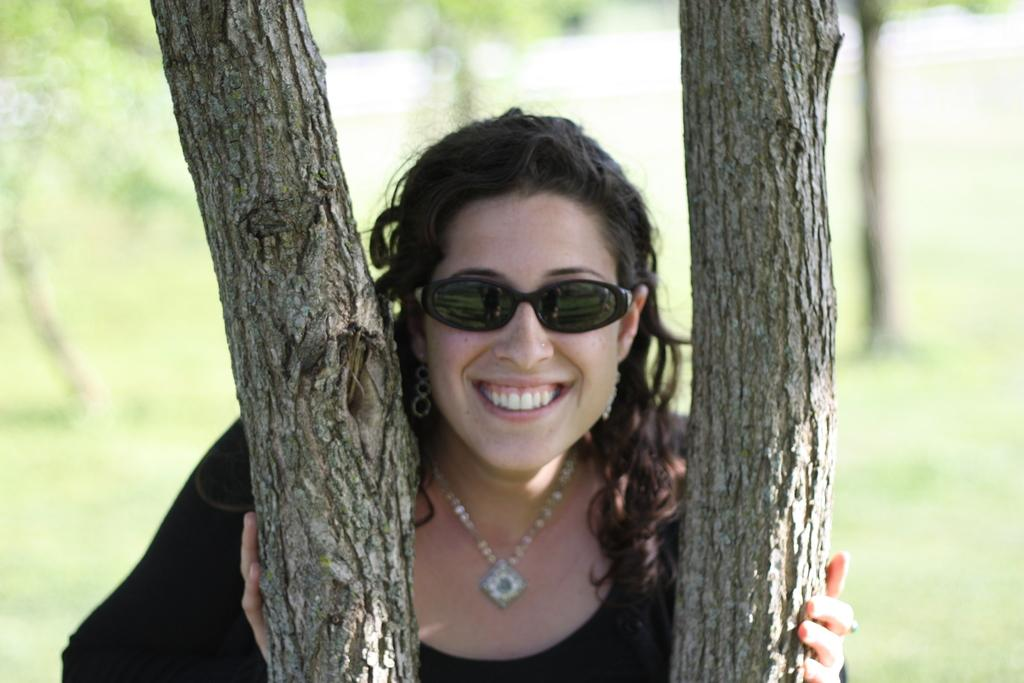Who is the main subject in the image? There is a lady in the image. What is the lady doing in the image? The lady is standing and smiling. What can be seen in the background of the image? There are trees in the background of the image. What type of gun is the lady holding in the image? There is no gun present in the image; the lady is simply standing and smiling. 